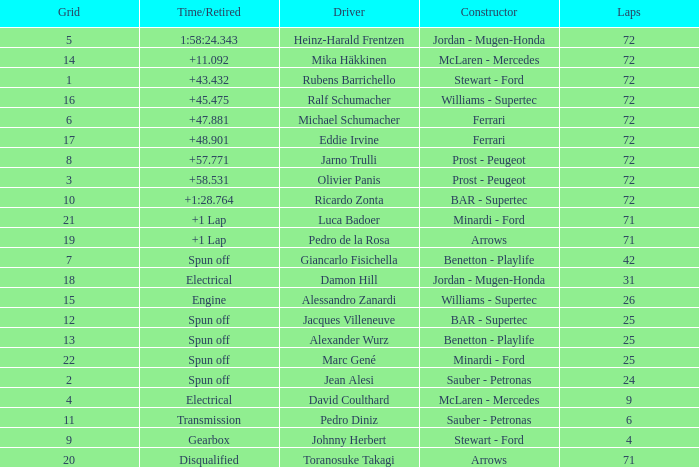What was Alexander Wurz's highest grid with laps of less than 25? None. Would you mind parsing the complete table? {'header': ['Grid', 'Time/Retired', 'Driver', 'Constructor', 'Laps'], 'rows': [['5', '1:58:24.343', 'Heinz-Harald Frentzen', 'Jordan - Mugen-Honda', '72'], ['14', '+11.092', 'Mika Häkkinen', 'McLaren - Mercedes', '72'], ['1', '+43.432', 'Rubens Barrichello', 'Stewart - Ford', '72'], ['16', '+45.475', 'Ralf Schumacher', 'Williams - Supertec', '72'], ['6', '+47.881', 'Michael Schumacher', 'Ferrari', '72'], ['17', '+48.901', 'Eddie Irvine', 'Ferrari', '72'], ['8', '+57.771', 'Jarno Trulli', 'Prost - Peugeot', '72'], ['3', '+58.531', 'Olivier Panis', 'Prost - Peugeot', '72'], ['10', '+1:28.764', 'Ricardo Zonta', 'BAR - Supertec', '72'], ['21', '+1 Lap', 'Luca Badoer', 'Minardi - Ford', '71'], ['19', '+1 Lap', 'Pedro de la Rosa', 'Arrows', '71'], ['7', 'Spun off', 'Giancarlo Fisichella', 'Benetton - Playlife', '42'], ['18', 'Electrical', 'Damon Hill', 'Jordan - Mugen-Honda', '31'], ['15', 'Engine', 'Alessandro Zanardi', 'Williams - Supertec', '26'], ['12', 'Spun off', 'Jacques Villeneuve', 'BAR - Supertec', '25'], ['13', 'Spun off', 'Alexander Wurz', 'Benetton - Playlife', '25'], ['22', 'Spun off', 'Marc Gené', 'Minardi - Ford', '25'], ['2', 'Spun off', 'Jean Alesi', 'Sauber - Petronas', '24'], ['4', 'Electrical', 'David Coulthard', 'McLaren - Mercedes', '9'], ['11', 'Transmission', 'Pedro Diniz', 'Sauber - Petronas', '6'], ['9', 'Gearbox', 'Johnny Herbert', 'Stewart - Ford', '4'], ['20', 'Disqualified', 'Toranosuke Takagi', 'Arrows', '71']]} 